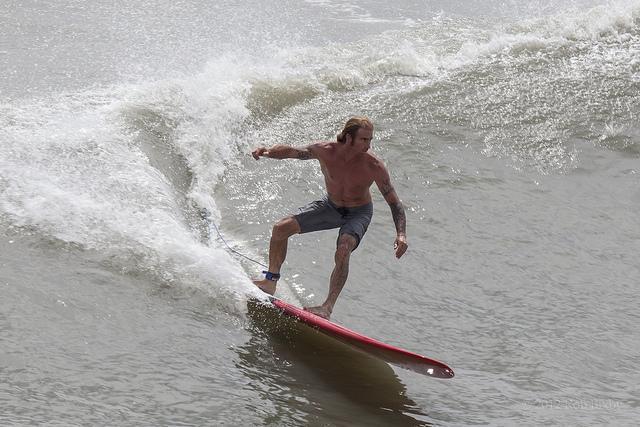How many people are surfing?
Give a very brief answer. 1. 